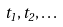<formula> <loc_0><loc_0><loc_500><loc_500>t _ { 1 } , t _ { 2 } , \dots</formula> 